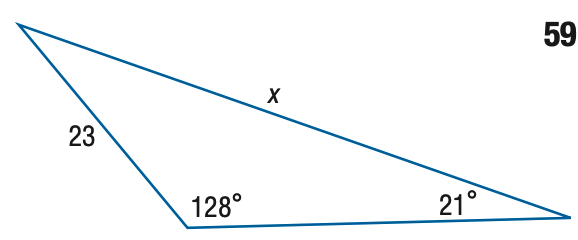Question: Find x. Round the side measure to the nearest tenth.
Choices:
A. 10.5
B. 15.0
C. 35.2
D. 50.6
Answer with the letter. Answer: D 